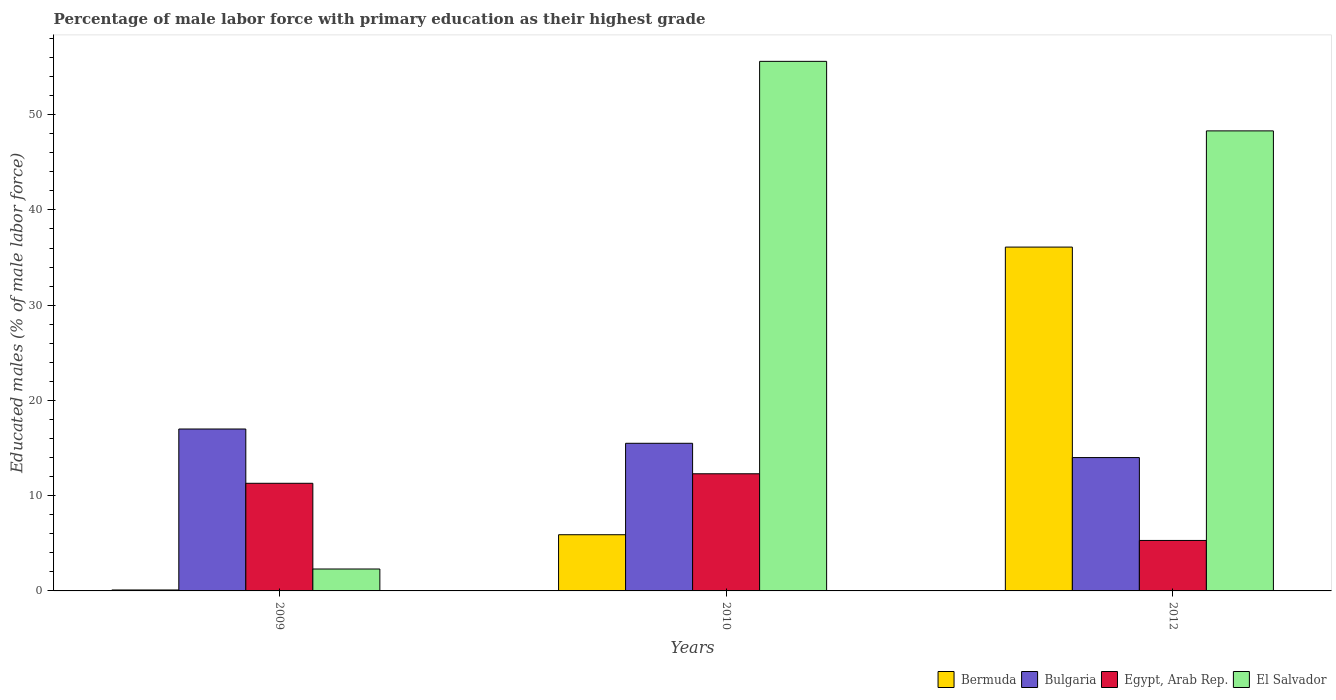Are the number of bars per tick equal to the number of legend labels?
Give a very brief answer. Yes. Are the number of bars on each tick of the X-axis equal?
Keep it short and to the point. Yes. How many bars are there on the 3rd tick from the left?
Provide a short and direct response. 4. How many bars are there on the 2nd tick from the right?
Ensure brevity in your answer.  4. What is the label of the 3rd group of bars from the left?
Your answer should be compact. 2012. In how many cases, is the number of bars for a given year not equal to the number of legend labels?
Provide a short and direct response. 0. What is the percentage of male labor force with primary education in Bermuda in 2009?
Give a very brief answer. 0.1. Across all years, what is the maximum percentage of male labor force with primary education in Egypt, Arab Rep.?
Offer a terse response. 12.3. In which year was the percentage of male labor force with primary education in Egypt, Arab Rep. maximum?
Provide a short and direct response. 2010. In which year was the percentage of male labor force with primary education in Bermuda minimum?
Provide a short and direct response. 2009. What is the total percentage of male labor force with primary education in Bermuda in the graph?
Offer a very short reply. 42.1. What is the difference between the percentage of male labor force with primary education in Egypt, Arab Rep. in 2009 and that in 2010?
Your answer should be very brief. -1. What is the difference between the percentage of male labor force with primary education in Bulgaria in 2010 and the percentage of male labor force with primary education in Bermuda in 2012?
Ensure brevity in your answer.  -20.6. In the year 2009, what is the difference between the percentage of male labor force with primary education in Bulgaria and percentage of male labor force with primary education in Bermuda?
Provide a short and direct response. 16.9. In how many years, is the percentage of male labor force with primary education in Bermuda greater than 30 %?
Your answer should be very brief. 1. What is the ratio of the percentage of male labor force with primary education in Bermuda in 2010 to that in 2012?
Your answer should be compact. 0.16. Is the difference between the percentage of male labor force with primary education in Bulgaria in 2009 and 2010 greater than the difference between the percentage of male labor force with primary education in Bermuda in 2009 and 2010?
Offer a very short reply. Yes. What is the difference between the highest and the second highest percentage of male labor force with primary education in Bulgaria?
Offer a very short reply. 1.5. What is the difference between the highest and the lowest percentage of male labor force with primary education in Egypt, Arab Rep.?
Make the answer very short. 7. Is the sum of the percentage of male labor force with primary education in Bulgaria in 2009 and 2012 greater than the maximum percentage of male labor force with primary education in El Salvador across all years?
Your answer should be compact. No. Is it the case that in every year, the sum of the percentage of male labor force with primary education in Egypt, Arab Rep. and percentage of male labor force with primary education in Bermuda is greater than the sum of percentage of male labor force with primary education in El Salvador and percentage of male labor force with primary education in Bulgaria?
Give a very brief answer. Yes. What does the 1st bar from the left in 2009 represents?
Make the answer very short. Bermuda. What does the 1st bar from the right in 2009 represents?
Make the answer very short. El Salvador. Are all the bars in the graph horizontal?
Offer a very short reply. No. Are the values on the major ticks of Y-axis written in scientific E-notation?
Keep it short and to the point. No. Does the graph contain any zero values?
Ensure brevity in your answer.  No. Does the graph contain grids?
Give a very brief answer. No. What is the title of the graph?
Your answer should be very brief. Percentage of male labor force with primary education as their highest grade. What is the label or title of the Y-axis?
Provide a succinct answer. Educated males (% of male labor force). What is the Educated males (% of male labor force) of Bermuda in 2009?
Your answer should be compact. 0.1. What is the Educated males (% of male labor force) in Bulgaria in 2009?
Give a very brief answer. 17. What is the Educated males (% of male labor force) of Egypt, Arab Rep. in 2009?
Keep it short and to the point. 11.3. What is the Educated males (% of male labor force) of El Salvador in 2009?
Make the answer very short. 2.3. What is the Educated males (% of male labor force) of Bermuda in 2010?
Your response must be concise. 5.9. What is the Educated males (% of male labor force) in Egypt, Arab Rep. in 2010?
Ensure brevity in your answer.  12.3. What is the Educated males (% of male labor force) in El Salvador in 2010?
Make the answer very short. 55.6. What is the Educated males (% of male labor force) of Bermuda in 2012?
Give a very brief answer. 36.1. What is the Educated males (% of male labor force) in Bulgaria in 2012?
Provide a succinct answer. 14. What is the Educated males (% of male labor force) of Egypt, Arab Rep. in 2012?
Keep it short and to the point. 5.3. What is the Educated males (% of male labor force) in El Salvador in 2012?
Ensure brevity in your answer.  48.3. Across all years, what is the maximum Educated males (% of male labor force) of Bermuda?
Your answer should be compact. 36.1. Across all years, what is the maximum Educated males (% of male labor force) of Egypt, Arab Rep.?
Your answer should be very brief. 12.3. Across all years, what is the maximum Educated males (% of male labor force) of El Salvador?
Provide a short and direct response. 55.6. Across all years, what is the minimum Educated males (% of male labor force) of Bermuda?
Offer a very short reply. 0.1. Across all years, what is the minimum Educated males (% of male labor force) of Egypt, Arab Rep.?
Offer a very short reply. 5.3. Across all years, what is the minimum Educated males (% of male labor force) in El Salvador?
Keep it short and to the point. 2.3. What is the total Educated males (% of male labor force) of Bermuda in the graph?
Your answer should be very brief. 42.1. What is the total Educated males (% of male labor force) of Bulgaria in the graph?
Keep it short and to the point. 46.5. What is the total Educated males (% of male labor force) in Egypt, Arab Rep. in the graph?
Offer a very short reply. 28.9. What is the total Educated males (% of male labor force) of El Salvador in the graph?
Your answer should be compact. 106.2. What is the difference between the Educated males (% of male labor force) of Bulgaria in 2009 and that in 2010?
Your answer should be very brief. 1.5. What is the difference between the Educated males (% of male labor force) of El Salvador in 2009 and that in 2010?
Your answer should be very brief. -53.3. What is the difference between the Educated males (% of male labor force) of Bermuda in 2009 and that in 2012?
Ensure brevity in your answer.  -36. What is the difference between the Educated males (% of male labor force) in Bulgaria in 2009 and that in 2012?
Offer a terse response. 3. What is the difference between the Educated males (% of male labor force) of El Salvador in 2009 and that in 2012?
Your response must be concise. -46. What is the difference between the Educated males (% of male labor force) in Bermuda in 2010 and that in 2012?
Offer a terse response. -30.2. What is the difference between the Educated males (% of male labor force) of Bulgaria in 2010 and that in 2012?
Your answer should be very brief. 1.5. What is the difference between the Educated males (% of male labor force) of Bermuda in 2009 and the Educated males (% of male labor force) of Bulgaria in 2010?
Your response must be concise. -15.4. What is the difference between the Educated males (% of male labor force) of Bermuda in 2009 and the Educated males (% of male labor force) of El Salvador in 2010?
Offer a terse response. -55.5. What is the difference between the Educated males (% of male labor force) of Bulgaria in 2009 and the Educated males (% of male labor force) of Egypt, Arab Rep. in 2010?
Offer a very short reply. 4.7. What is the difference between the Educated males (% of male labor force) in Bulgaria in 2009 and the Educated males (% of male labor force) in El Salvador in 2010?
Make the answer very short. -38.6. What is the difference between the Educated males (% of male labor force) in Egypt, Arab Rep. in 2009 and the Educated males (% of male labor force) in El Salvador in 2010?
Ensure brevity in your answer.  -44.3. What is the difference between the Educated males (% of male labor force) of Bermuda in 2009 and the Educated males (% of male labor force) of Bulgaria in 2012?
Offer a very short reply. -13.9. What is the difference between the Educated males (% of male labor force) in Bermuda in 2009 and the Educated males (% of male labor force) in Egypt, Arab Rep. in 2012?
Offer a very short reply. -5.2. What is the difference between the Educated males (% of male labor force) of Bermuda in 2009 and the Educated males (% of male labor force) of El Salvador in 2012?
Give a very brief answer. -48.2. What is the difference between the Educated males (% of male labor force) in Bulgaria in 2009 and the Educated males (% of male labor force) in Egypt, Arab Rep. in 2012?
Offer a very short reply. 11.7. What is the difference between the Educated males (% of male labor force) of Bulgaria in 2009 and the Educated males (% of male labor force) of El Salvador in 2012?
Ensure brevity in your answer.  -31.3. What is the difference between the Educated males (% of male labor force) in Egypt, Arab Rep. in 2009 and the Educated males (% of male labor force) in El Salvador in 2012?
Your answer should be very brief. -37. What is the difference between the Educated males (% of male labor force) in Bermuda in 2010 and the Educated males (% of male labor force) in Bulgaria in 2012?
Offer a terse response. -8.1. What is the difference between the Educated males (% of male labor force) of Bermuda in 2010 and the Educated males (% of male labor force) of El Salvador in 2012?
Your response must be concise. -42.4. What is the difference between the Educated males (% of male labor force) in Bulgaria in 2010 and the Educated males (% of male labor force) in Egypt, Arab Rep. in 2012?
Your answer should be compact. 10.2. What is the difference between the Educated males (% of male labor force) of Bulgaria in 2010 and the Educated males (% of male labor force) of El Salvador in 2012?
Give a very brief answer. -32.8. What is the difference between the Educated males (% of male labor force) of Egypt, Arab Rep. in 2010 and the Educated males (% of male labor force) of El Salvador in 2012?
Ensure brevity in your answer.  -36. What is the average Educated males (% of male labor force) of Bermuda per year?
Your answer should be very brief. 14.03. What is the average Educated males (% of male labor force) in Egypt, Arab Rep. per year?
Provide a succinct answer. 9.63. What is the average Educated males (% of male labor force) of El Salvador per year?
Give a very brief answer. 35.4. In the year 2009, what is the difference between the Educated males (% of male labor force) in Bermuda and Educated males (% of male labor force) in Bulgaria?
Make the answer very short. -16.9. In the year 2009, what is the difference between the Educated males (% of male labor force) in Bermuda and Educated males (% of male labor force) in El Salvador?
Your response must be concise. -2.2. In the year 2009, what is the difference between the Educated males (% of male labor force) in Bulgaria and Educated males (% of male labor force) in El Salvador?
Offer a terse response. 14.7. In the year 2009, what is the difference between the Educated males (% of male labor force) of Egypt, Arab Rep. and Educated males (% of male labor force) of El Salvador?
Ensure brevity in your answer.  9. In the year 2010, what is the difference between the Educated males (% of male labor force) in Bermuda and Educated males (% of male labor force) in Bulgaria?
Give a very brief answer. -9.6. In the year 2010, what is the difference between the Educated males (% of male labor force) in Bermuda and Educated males (% of male labor force) in Egypt, Arab Rep.?
Ensure brevity in your answer.  -6.4. In the year 2010, what is the difference between the Educated males (% of male labor force) of Bermuda and Educated males (% of male labor force) of El Salvador?
Your response must be concise. -49.7. In the year 2010, what is the difference between the Educated males (% of male labor force) of Bulgaria and Educated males (% of male labor force) of Egypt, Arab Rep.?
Provide a succinct answer. 3.2. In the year 2010, what is the difference between the Educated males (% of male labor force) in Bulgaria and Educated males (% of male labor force) in El Salvador?
Give a very brief answer. -40.1. In the year 2010, what is the difference between the Educated males (% of male labor force) of Egypt, Arab Rep. and Educated males (% of male labor force) of El Salvador?
Offer a very short reply. -43.3. In the year 2012, what is the difference between the Educated males (% of male labor force) in Bermuda and Educated males (% of male labor force) in Bulgaria?
Give a very brief answer. 22.1. In the year 2012, what is the difference between the Educated males (% of male labor force) in Bermuda and Educated males (% of male labor force) in Egypt, Arab Rep.?
Offer a terse response. 30.8. In the year 2012, what is the difference between the Educated males (% of male labor force) in Bulgaria and Educated males (% of male labor force) in El Salvador?
Offer a terse response. -34.3. In the year 2012, what is the difference between the Educated males (% of male labor force) in Egypt, Arab Rep. and Educated males (% of male labor force) in El Salvador?
Provide a short and direct response. -43. What is the ratio of the Educated males (% of male labor force) of Bermuda in 2009 to that in 2010?
Offer a very short reply. 0.02. What is the ratio of the Educated males (% of male labor force) in Bulgaria in 2009 to that in 2010?
Provide a short and direct response. 1.1. What is the ratio of the Educated males (% of male labor force) in Egypt, Arab Rep. in 2009 to that in 2010?
Offer a terse response. 0.92. What is the ratio of the Educated males (% of male labor force) of El Salvador in 2009 to that in 2010?
Make the answer very short. 0.04. What is the ratio of the Educated males (% of male labor force) of Bermuda in 2009 to that in 2012?
Give a very brief answer. 0. What is the ratio of the Educated males (% of male labor force) in Bulgaria in 2009 to that in 2012?
Your response must be concise. 1.21. What is the ratio of the Educated males (% of male labor force) of Egypt, Arab Rep. in 2009 to that in 2012?
Provide a succinct answer. 2.13. What is the ratio of the Educated males (% of male labor force) in El Salvador in 2009 to that in 2012?
Provide a succinct answer. 0.05. What is the ratio of the Educated males (% of male labor force) of Bermuda in 2010 to that in 2012?
Offer a very short reply. 0.16. What is the ratio of the Educated males (% of male labor force) in Bulgaria in 2010 to that in 2012?
Offer a terse response. 1.11. What is the ratio of the Educated males (% of male labor force) of Egypt, Arab Rep. in 2010 to that in 2012?
Offer a terse response. 2.32. What is the ratio of the Educated males (% of male labor force) in El Salvador in 2010 to that in 2012?
Give a very brief answer. 1.15. What is the difference between the highest and the second highest Educated males (% of male labor force) in Bermuda?
Make the answer very short. 30.2. What is the difference between the highest and the second highest Educated males (% of male labor force) in Bulgaria?
Your response must be concise. 1.5. What is the difference between the highest and the second highest Educated males (% of male labor force) of El Salvador?
Give a very brief answer. 7.3. What is the difference between the highest and the lowest Educated males (% of male labor force) in Bermuda?
Keep it short and to the point. 36. What is the difference between the highest and the lowest Educated males (% of male labor force) of Bulgaria?
Your response must be concise. 3. What is the difference between the highest and the lowest Educated males (% of male labor force) of Egypt, Arab Rep.?
Offer a very short reply. 7. What is the difference between the highest and the lowest Educated males (% of male labor force) of El Salvador?
Your answer should be compact. 53.3. 